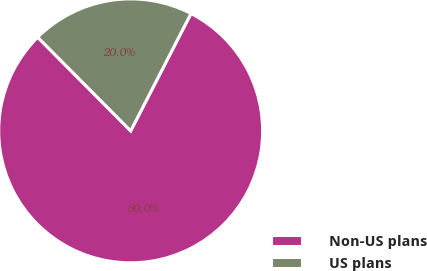Convert chart. <chart><loc_0><loc_0><loc_500><loc_500><pie_chart><fcel>Non-US plans<fcel>US plans<nl><fcel>80.0%<fcel>20.0%<nl></chart> 